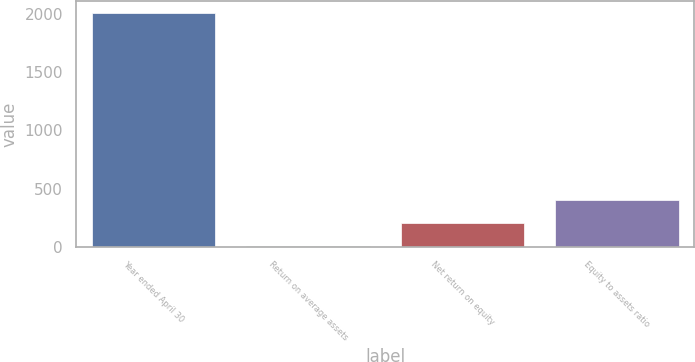Convert chart. <chart><loc_0><loc_0><loc_500><loc_500><bar_chart><fcel>Year ended April 30<fcel>Return on average assets<fcel>Net return on equity<fcel>Equity to assets ratio<nl><fcel>2012<fcel>3.1<fcel>203.99<fcel>404.88<nl></chart> 